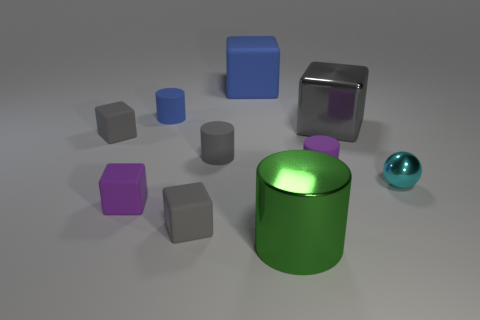How many other things are the same size as the cyan object?
Provide a short and direct response. 6. How many objects are purple rubber blocks or big objects left of the shiny cylinder?
Your answer should be very brief. 2. Are there an equal number of gray shiny objects in front of the small ball and gray cylinders?
Offer a terse response. No. What is the shape of the blue thing that is made of the same material as the big blue cube?
Make the answer very short. Cylinder. Are there any large metal cylinders of the same color as the small shiny thing?
Give a very brief answer. No. What number of metal objects are small yellow things or large gray cubes?
Provide a short and direct response. 1. There is a blue rubber object that is left of the big blue rubber block; what number of large metal cylinders are on the left side of it?
Provide a succinct answer. 0. How many tiny cyan things have the same material as the tiny blue cylinder?
Offer a terse response. 0. How many large things are purple objects or brown matte balls?
Provide a succinct answer. 0. What is the shape of the large object that is both behind the purple rubber cylinder and in front of the large blue matte cube?
Provide a succinct answer. Cube. 